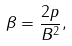<formula> <loc_0><loc_0><loc_500><loc_500>\beta = \frac { 2 p } { B ^ { 2 } } ,</formula> 